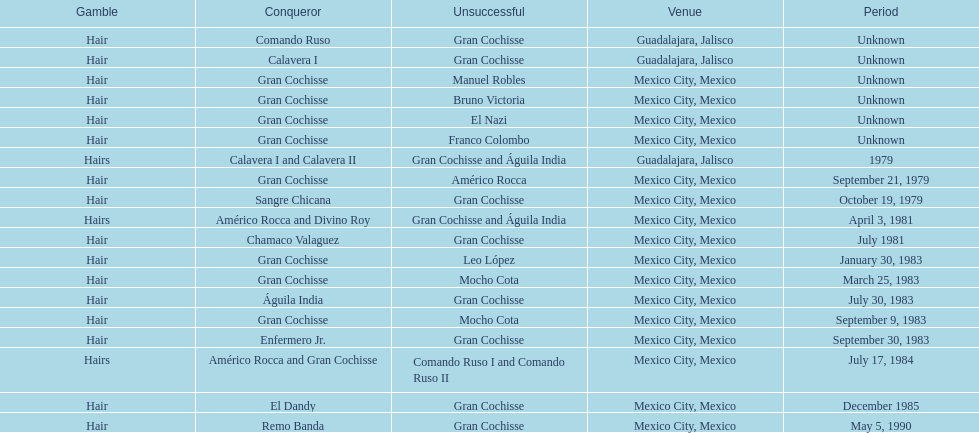How many times has the wager been hair? 16. 